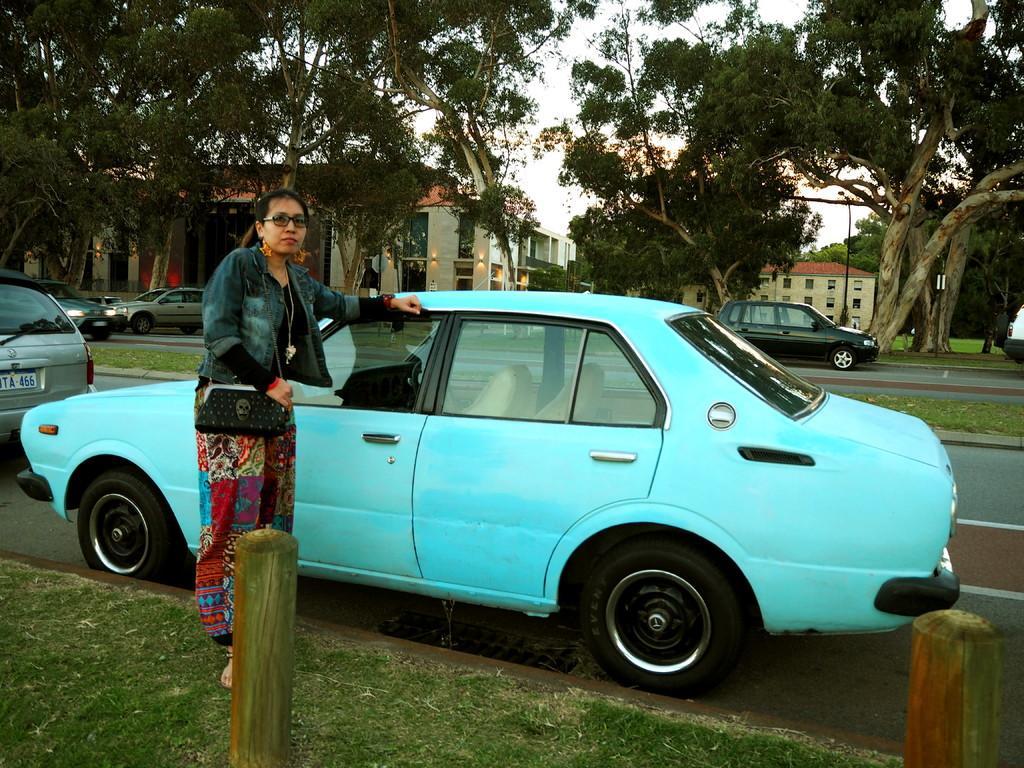Can you describe this image briefly? In this picture I can observe blue color car parked on the road. There is a woman standing beside the car. She is wearing spectacles. I can observe two wooden poles in this picture. In the background there are some trees, buildings and a sky. 